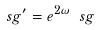<formula> <loc_0><loc_0><loc_500><loc_500>\ s g ^ { \prime } = e ^ { 2 \omega } \ s g</formula> 